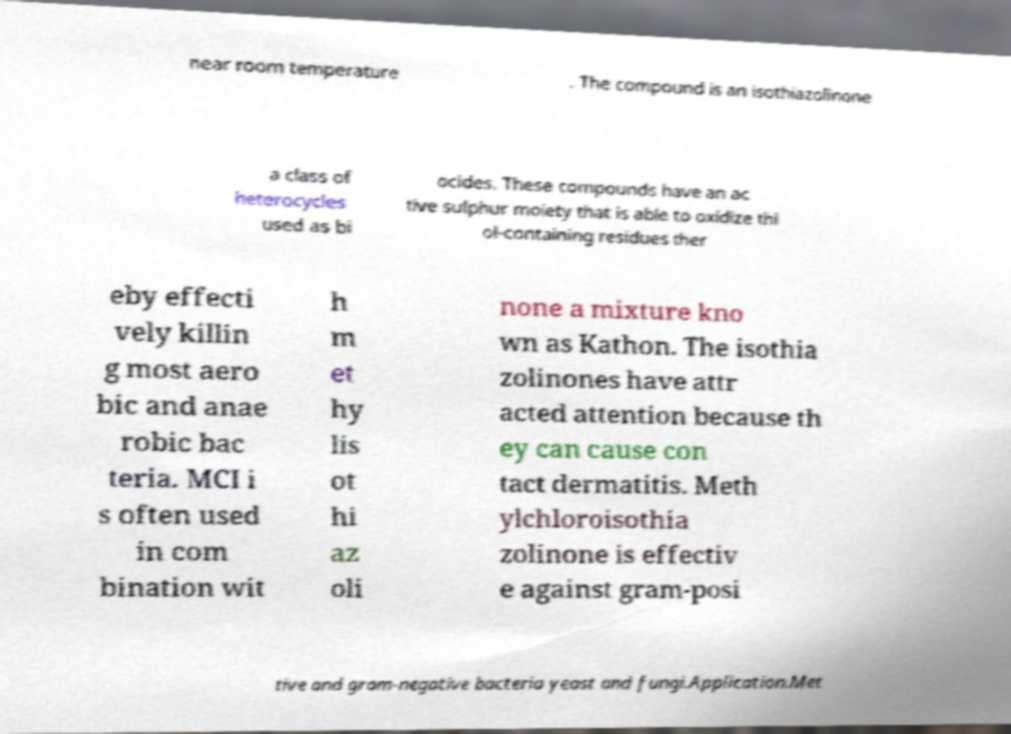What messages or text are displayed in this image? I need them in a readable, typed format. near room temperature . The compound is an isothiazolinone a class of heterocycles used as bi ocides. These compounds have an ac tive sulphur moiety that is able to oxidize thi ol-containing residues ther eby effecti vely killin g most aero bic and anae robic bac teria. MCI i s often used in com bination wit h m et hy lis ot hi az oli none a mixture kno wn as Kathon. The isothia zolinones have attr acted attention because th ey can cause con tact dermatitis. Meth ylchloroisothia zolinone is effectiv e against gram-posi tive and gram-negative bacteria yeast and fungi.Application.Met 